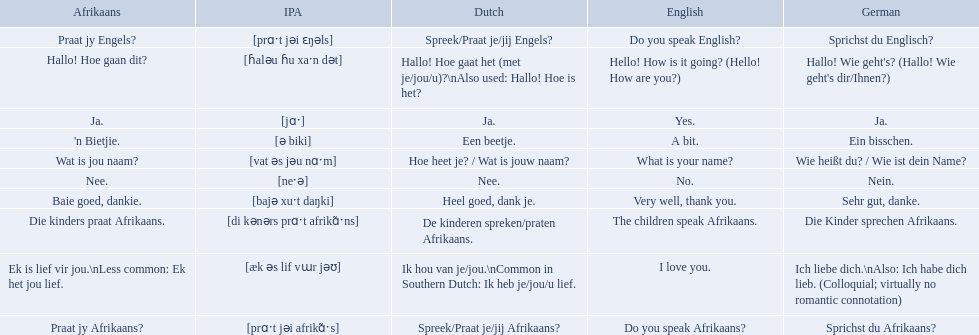How do you say hello! how is it going? in afrikaans? Hallo! Hoe gaan dit?. How do you say very well, thank you in afrikaans? Baie goed, dankie. How would you say do you speak afrikaans? in afrikaans? Praat jy Afrikaans?. 